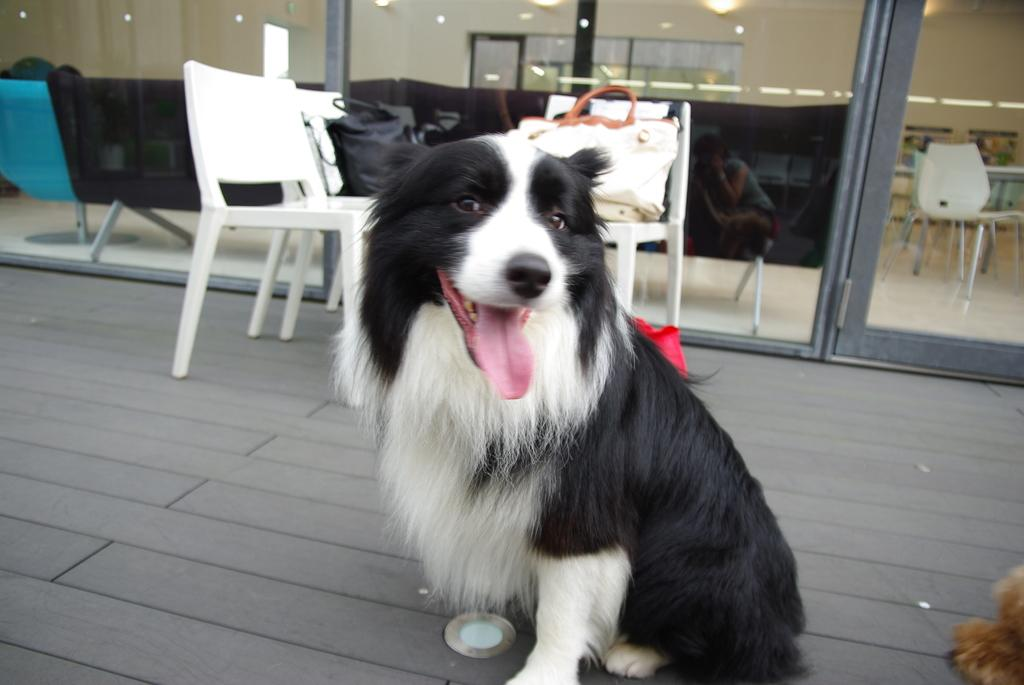What type of animal is in the image? There is a dog in the image. What furniture can be seen in the background of the image? There is a couch and a chair in the background of the image. What objects are present on the chair in the background? A handbag is present on the chair in the background. Can you describe the lighting in the image? There are lights in the background of the image. Is there a person visible in the image? Yes, there is a person in the background of the image. What type of wine is being served in the image? There is no wine present in the image. Can you describe the beetle that is crawling on the dog in the image? There is no beetle present in the image; only the dog, furniture, and people are visible. 